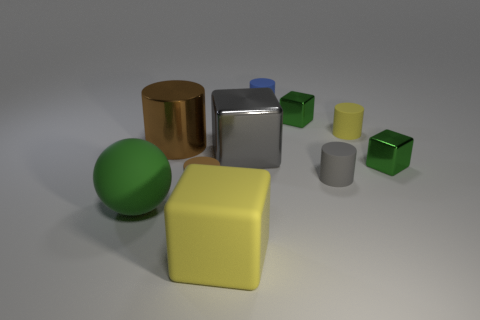Could you describe any patterns or design principles evident in the arrangement of these objects? One of the design principles at play could be the use of varying geometric shapes to create visual interest, such as spheres, cylinders, and cubes. The objects also have a balanced color distribution that does not overpower any part of the image. Moreover, the principle of scalability is represented with varying sizes of similar shapes. The image also seems to follow a soft light setting that creates a calm and even ambience without harsh shadows, emphasizing the shapes and materials of the objects. 